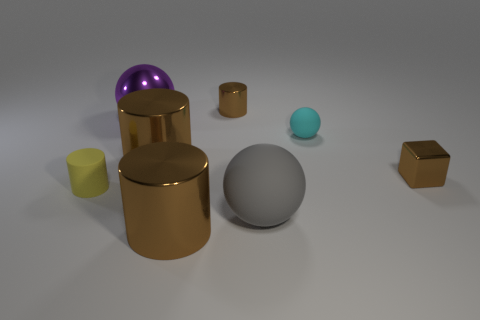What atmosphere or mood does the image convey? The image exudes a minimalist and modern vibe, with a clean background and muted colors that provide a calm and contemplative mood, possibly used in design or architectural contexts. 